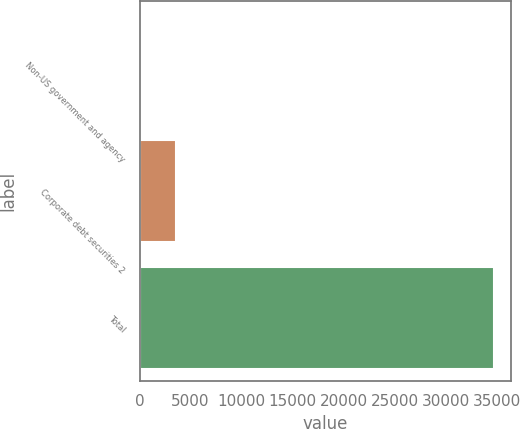Convert chart. <chart><loc_0><loc_0><loc_500><loc_500><bar_chart><fcel>Non-US government and agency<fcel>Corporate debt securities 2<fcel>Total<nl><fcel>148<fcel>3601.7<fcel>34685<nl></chart> 